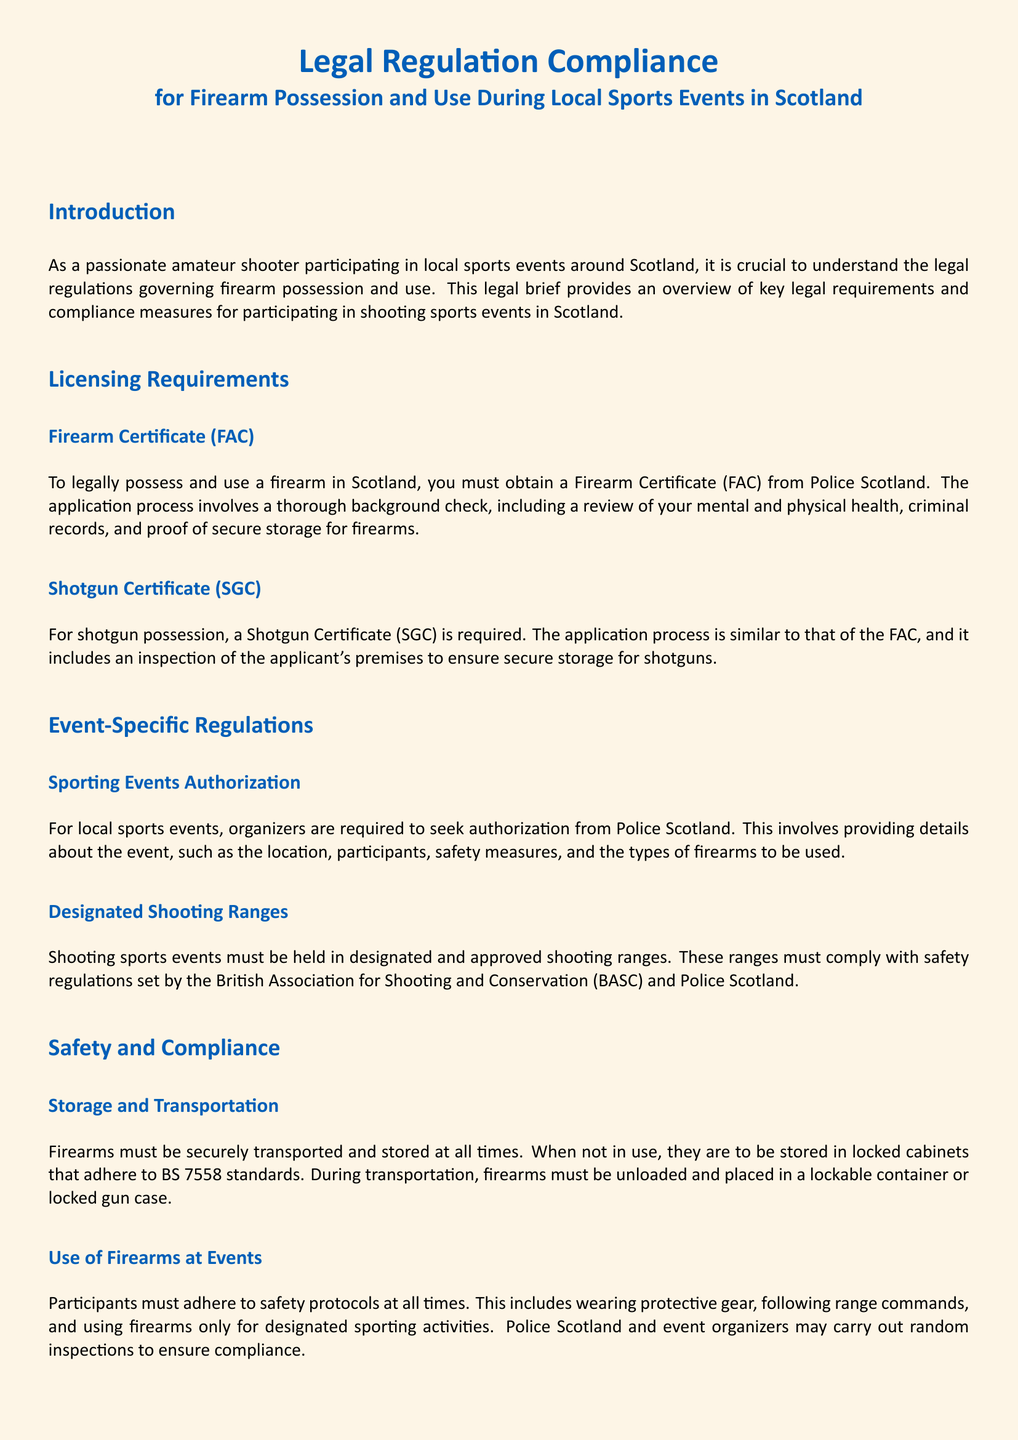What is required to legally possess a firearm in Scotland? The document states that a Firearm Certificate (FAC) is required to legally possess and use a firearm in Scotland.
Answer: Firearm Certificate (FAC) Who issues the Firearm Certificate? The document mentions that the Firearm Certificate (FAC) is issued by Police Scotland.
Answer: Police Scotland What is the email address for the Firearms Licensing Department? The document provides the contact email for the Firearms Licensing Department as firearms.licensing@scotland.pnn.police.uk.
Answer: firearms.licensing@scotland.pnn.police.uk What must be obtained for local sports events? According to the document, organizers must seek authorization from Police Scotland for local sports events.
Answer: Authorization from Police Scotland Which association outlines safety regulations for shooting events? The document states that the British Association for Shooting and Conservation (BASC) outlines safety regulations for shooting events.
Answer: British Association for Shooting and Conservation (BASC) What must be done with firearms when not in use? The document specifies that firearms must be stored in locked cabinets that adhere to BS 7558 standards when not in use.
Answer: Locked cabinets What type of containers should firearms be transported in? The document indicates that firearms must be placed in a lockable container or locked gun case during transportation.
Answer: Lockable container or locked gun case Which certificate is required for shotgun possession? The document mentions that a Shotgun Certificate (SGC) is required for shotgun possession.
Answer: Shotgun Certificate (SGC) What is essential for safe participation in shooting sports events? The document concludes that compliance with legal regulations governing firearm possession and use is essential for safe participation.
Answer: Compliance with legal regulations 